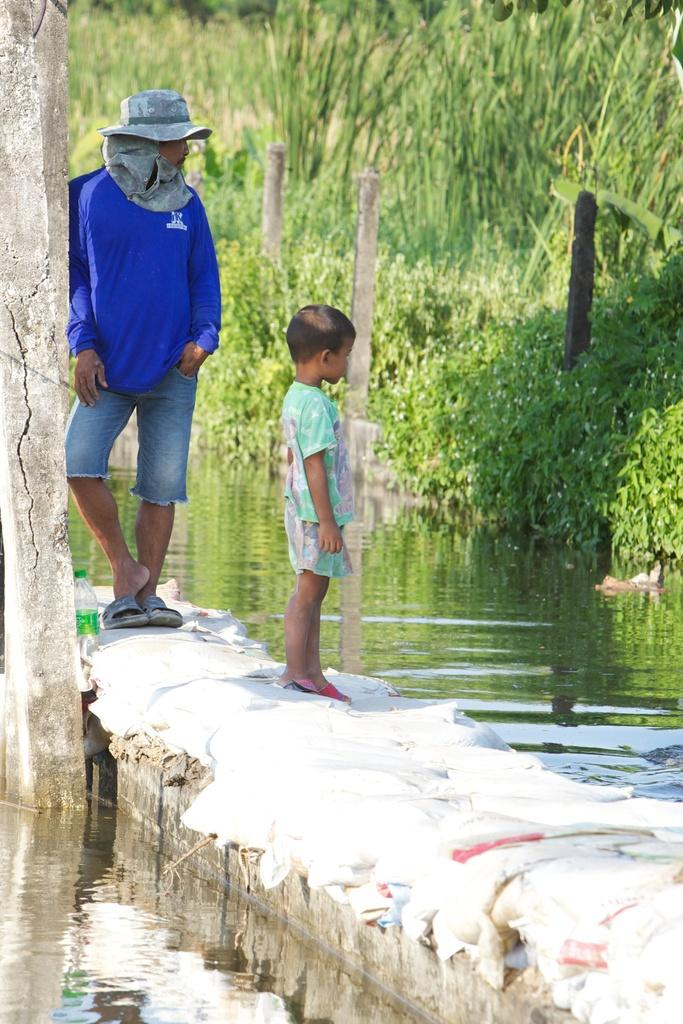How many people are in the image? There are persons standing in the image. What objects can be seen in the image besides the people? There are poles, a bottle, water, and plants visible in the image. What type of tree is growing on the shelf in the image? There is no shelf or tree present in the image. How does the sail affect the movement of the water in the image? There is no sail present in the image, so its effect on the water cannot be determined. 